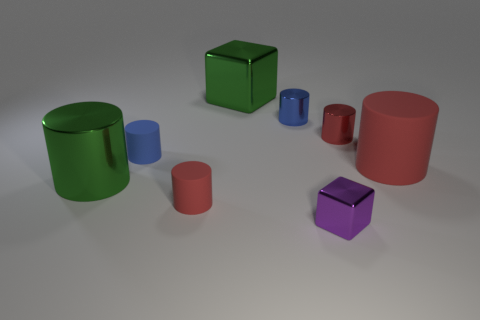Subtract all red shiny cylinders. How many cylinders are left? 5 Subtract all cyan balls. How many blue cylinders are left? 2 Subtract all cylinders. How many objects are left? 2 Add 7 green shiny spheres. How many green shiny spheres exist? 7 Add 1 large purple rubber cubes. How many objects exist? 9 Subtract all green cylinders. How many cylinders are left? 5 Subtract 0 red balls. How many objects are left? 8 Subtract 6 cylinders. How many cylinders are left? 0 Subtract all green cylinders. Subtract all brown blocks. How many cylinders are left? 5 Subtract all large cyan blocks. Subtract all rubber cylinders. How many objects are left? 5 